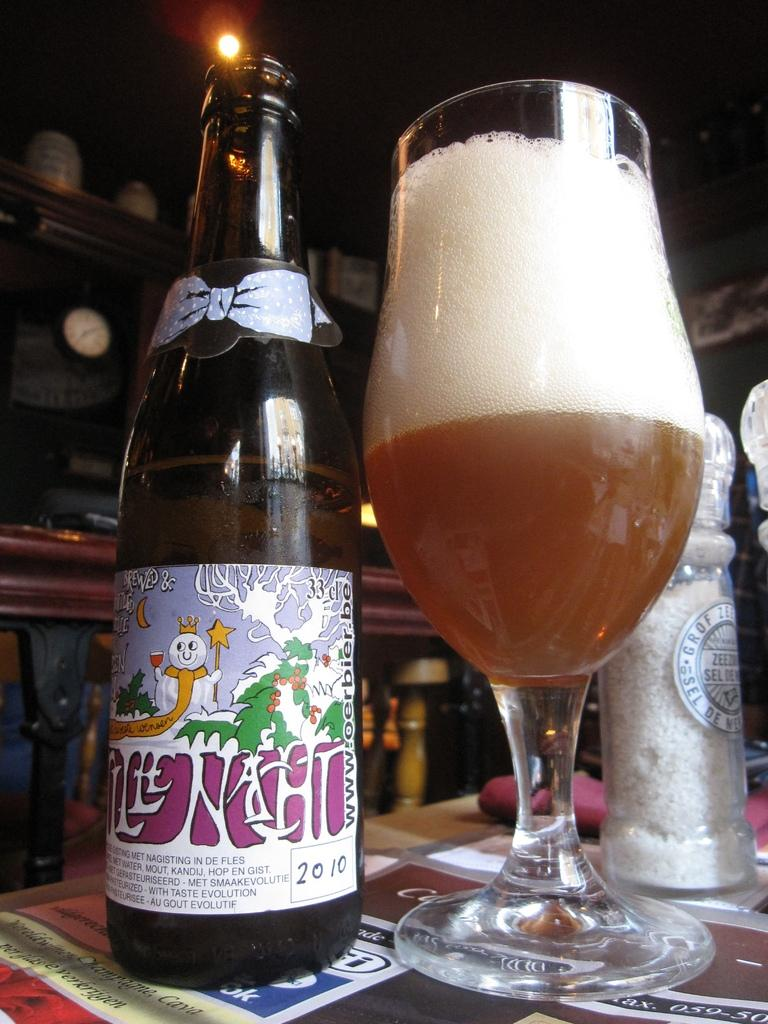<image>
Create a compact narrative representing the image presented. A bottle labeled with the year 2010 is on a table next to a glass. 